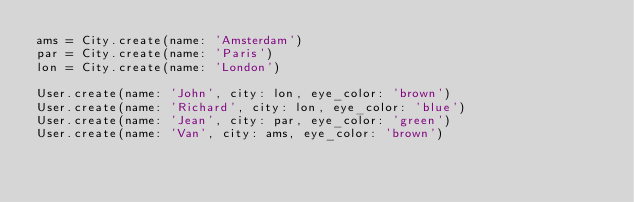<code> <loc_0><loc_0><loc_500><loc_500><_Ruby_>ams = City.create(name: 'Amsterdam')
par = City.create(name: 'Paris')
lon = City.create(name: 'London')

User.create(name: 'John', city: lon, eye_color: 'brown')
User.create(name: 'Richard', city: lon, eye_color: 'blue')
User.create(name: 'Jean', city: par, eye_color: 'green')
User.create(name: 'Van', city: ams, eye_color: 'brown')
</code> 